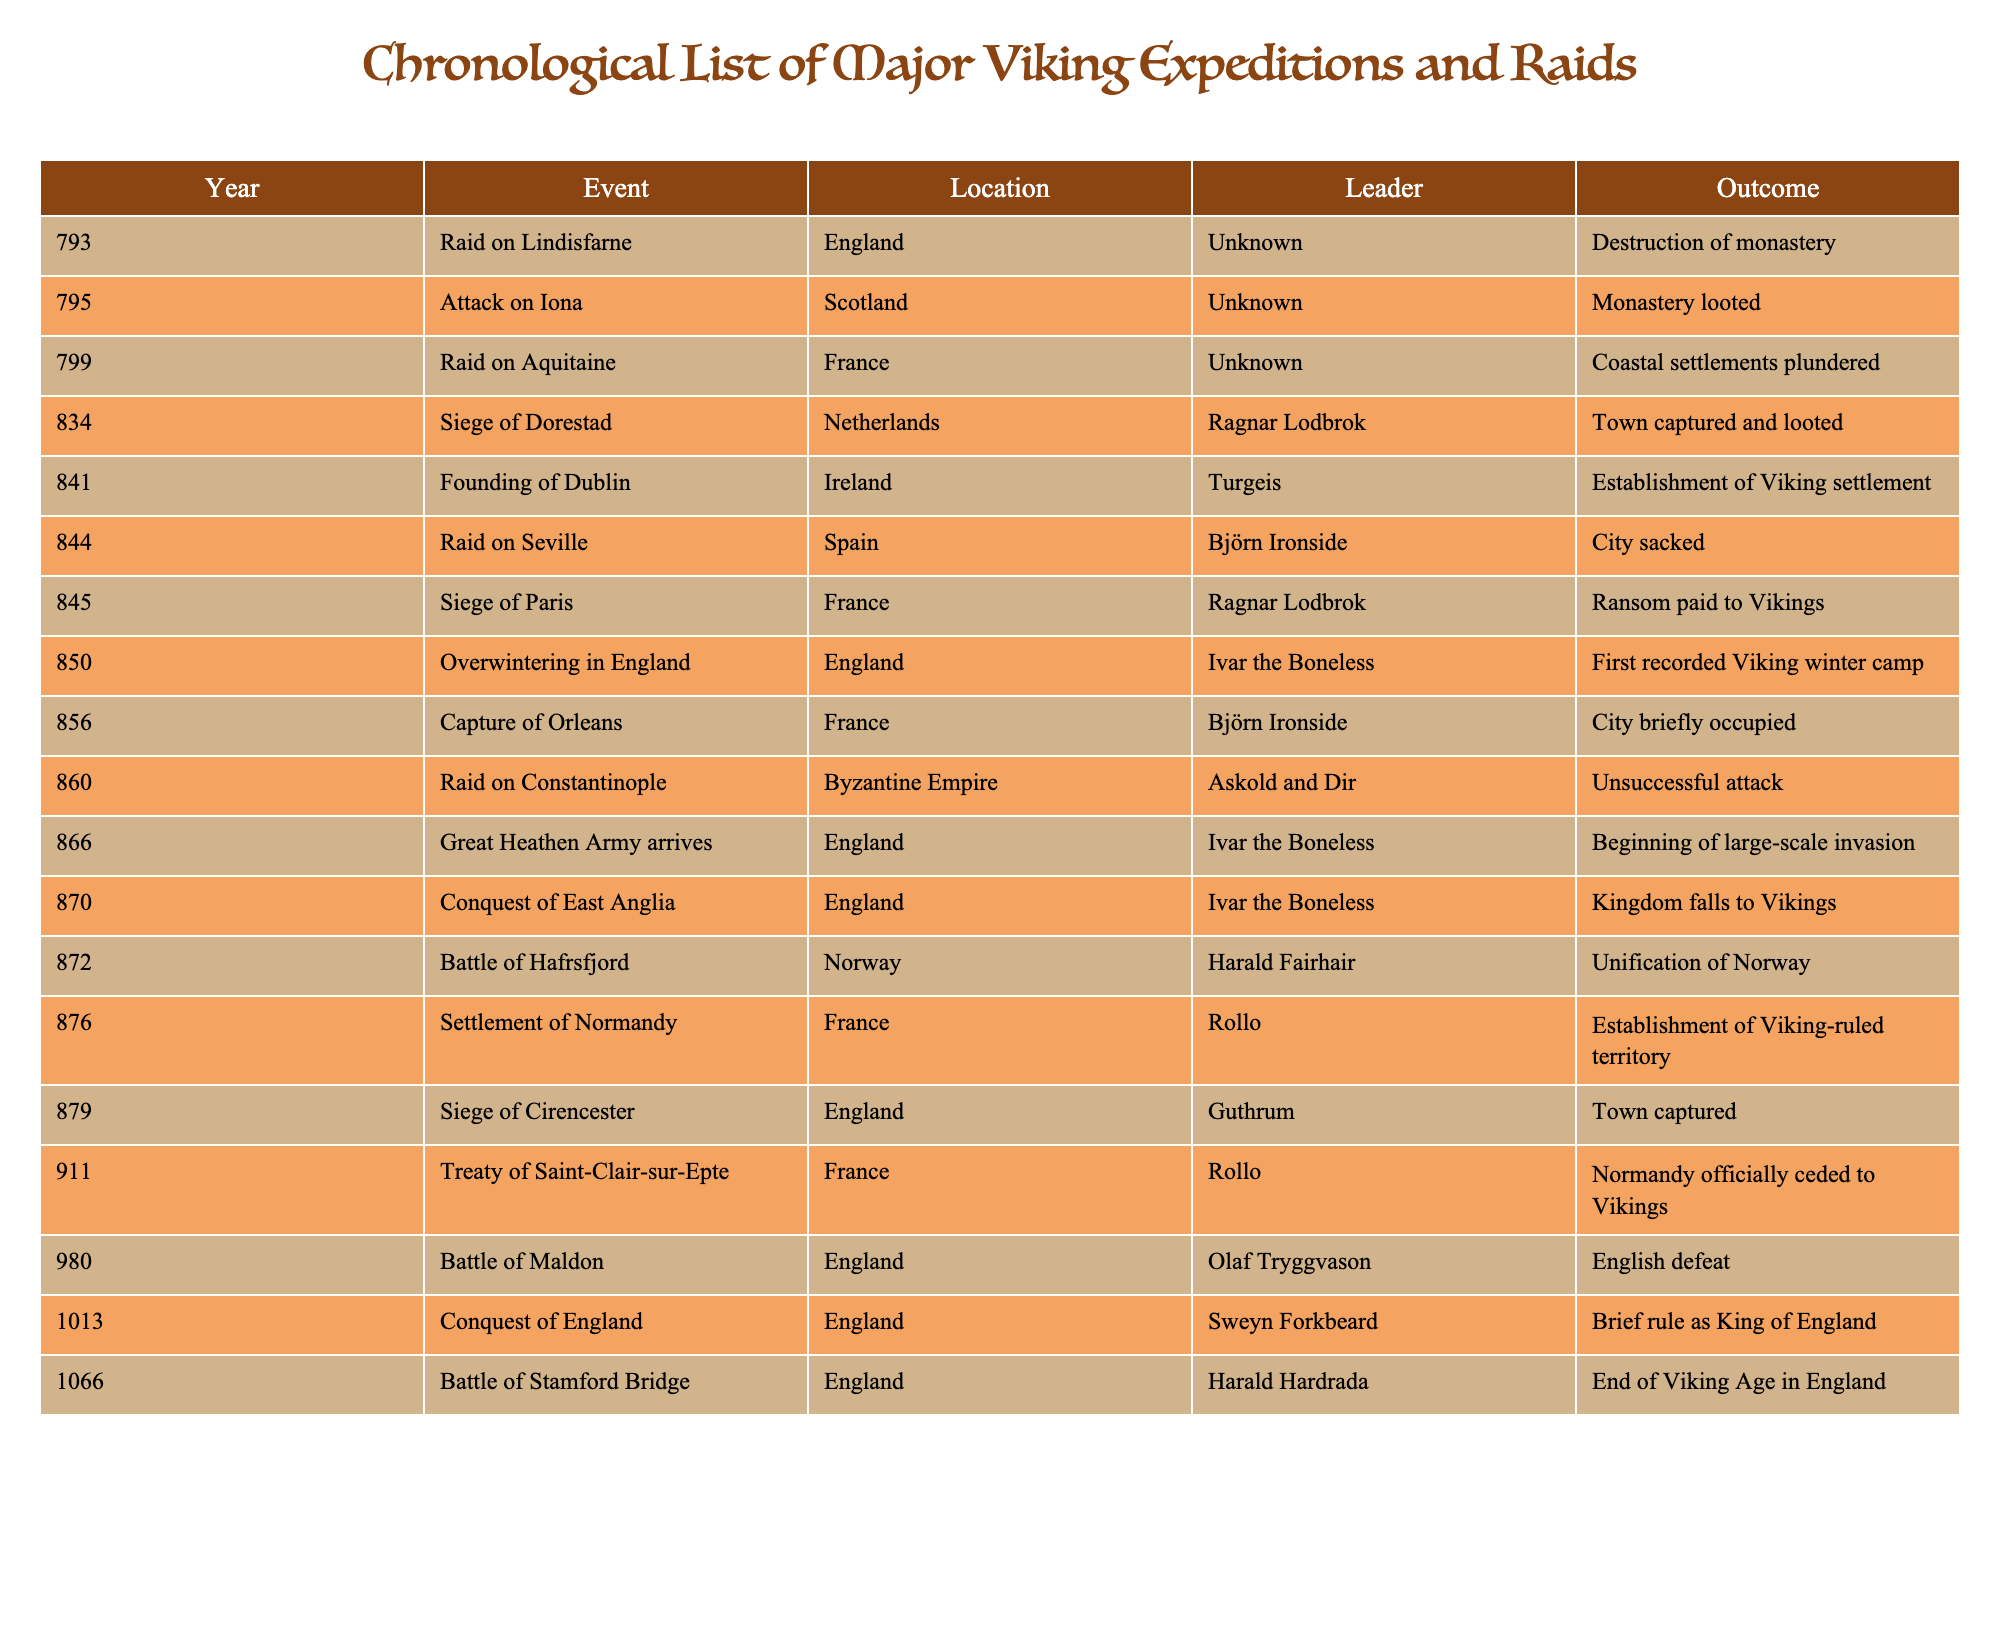What year did the raid on Lindisfarne occur? The table lists the year of the raid on Lindisfarne as 793. This is the specific row in the table corresponding to that event.
Answer: 793 Who led the siege of Paris? The table indicates that Ragnar Lodbrok was the leader of the siege of Paris, which is shown in the respective row of the table.
Answer: Ragnar Lodbrok What was the outcome of the attack on Iona? According to the table, the outcome of the attack on Iona was that the monastery was looted, as stated in the corresponding row.
Answer: Monastery looted Which event had an outcome of "Establishment of Viking settlement"? The table shows that the founding of Dublin had the outcome of "Establishment of Viking settlement," found in that row.
Answer: Founding of Dublin How many events listed occurred in England? By examining the location column, we see that there are 6 events related to England: the raid on Lindisfarne, siege of Paris, overwintering, conquest of East Anglia, siege of Cirencester, and the battle of Stamford Bridge. Therefore, there are a total of 6 events.
Answer: 6 What is the earliest year listed in the table? Scanning the Year column, the earliest year appears to be 793 for the raid on Lindisfarne, making it the minimum year noted.
Answer: 793 Which leader conquered England and in what year? The table indicates that Sweyn Forkbeard conquered England in the year 1013, as found in the relevant row.
Answer: Sweyn Forkbeard, 1013 Was the raid on Constantinople successful? The table specifies that the raid on Constantinople was an unsuccessful attack, based on the respective row's outcome.
Answer: No How many events resulted in towns being captured? Looking through the outcomes, the events that resulted in towns being captured are: siege of Dorestad, siege of Cirencester, and the raid on Constantinople, totaling 3 events where towns were taken.
Answer: 3 What percentage of the events result in destruction or plundering? There are 3 events that ended in destruction (Lindisfarne, the raid on Aquitaine, and the attack on Iona) or plundering (as part of being looted). With 15 total events, this amounts to 20% (3 out of 15).
Answer: 20% 